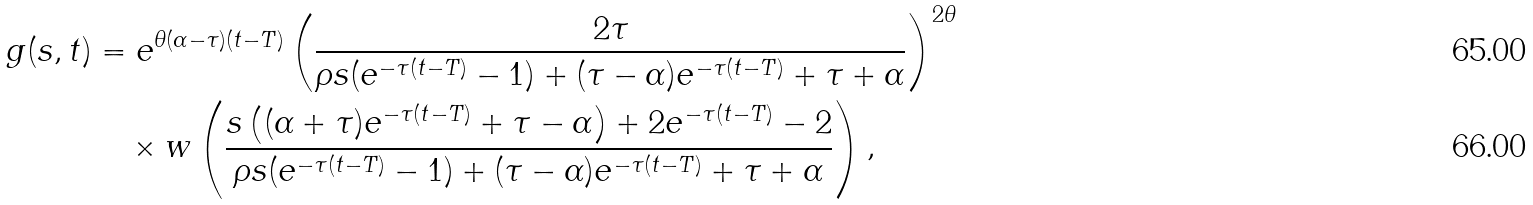Convert formula to latex. <formula><loc_0><loc_0><loc_500><loc_500>g ( s , t ) & = e ^ { \theta ( \alpha - \tau ) ( t - T ) } \left ( \frac { 2 \tau } { \rho s ( e ^ { - \tau ( t - T ) } - 1 ) + ( \tau - \alpha ) e ^ { - \tau ( t - T ) } + \tau + \alpha } \right ) ^ { 2 \theta } \\ & \quad \times w \left ( \frac { s \left ( ( \alpha + \tau ) e ^ { - \tau ( t - T ) } + \tau - \alpha \right ) + 2 e ^ { - \tau ( t - T ) } - 2 } { \rho s ( e ^ { - \tau ( t - T ) } - 1 ) + ( \tau - \alpha ) e ^ { - \tau ( t - T ) } + \tau + \alpha } \right ) ,</formula> 